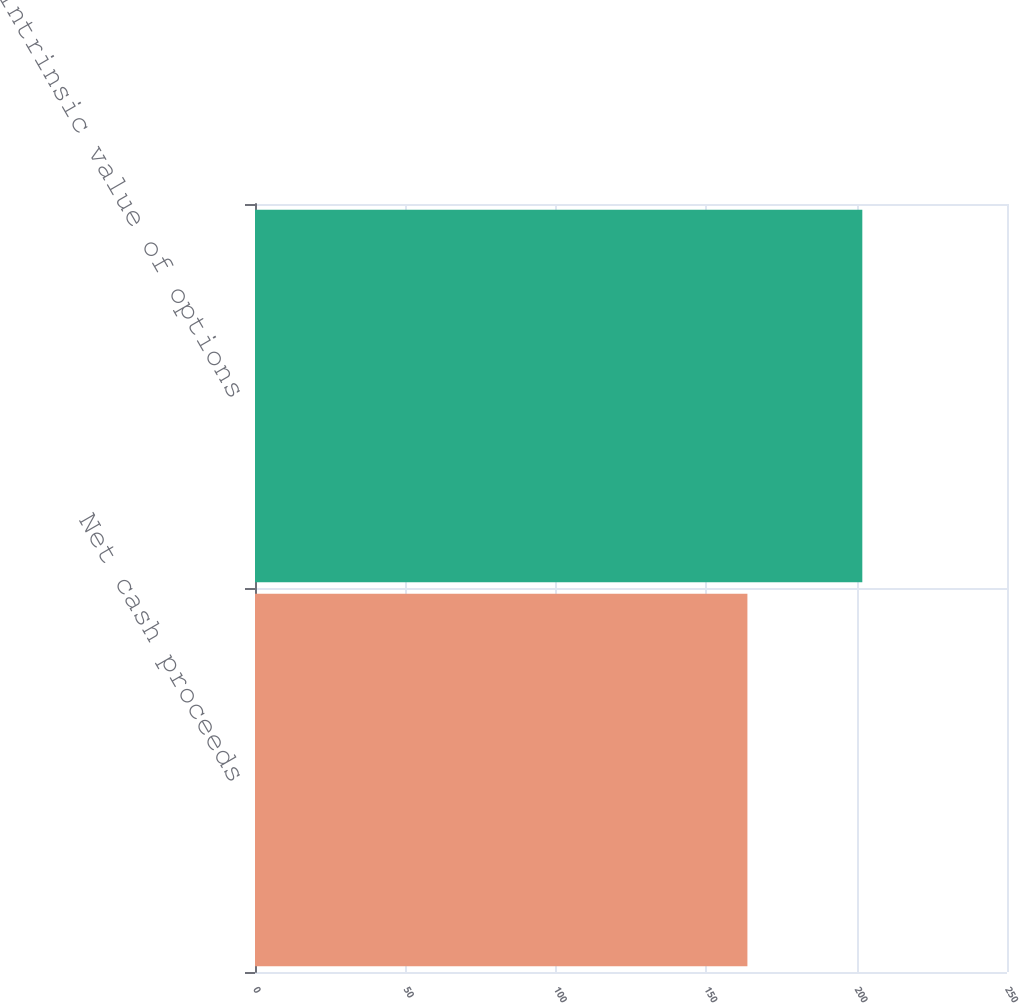Convert chart to OTSL. <chart><loc_0><loc_0><loc_500><loc_500><bar_chart><fcel>Net cash proceeds<fcel>Intrinsic value of options<nl><fcel>163.7<fcel>201.9<nl></chart> 